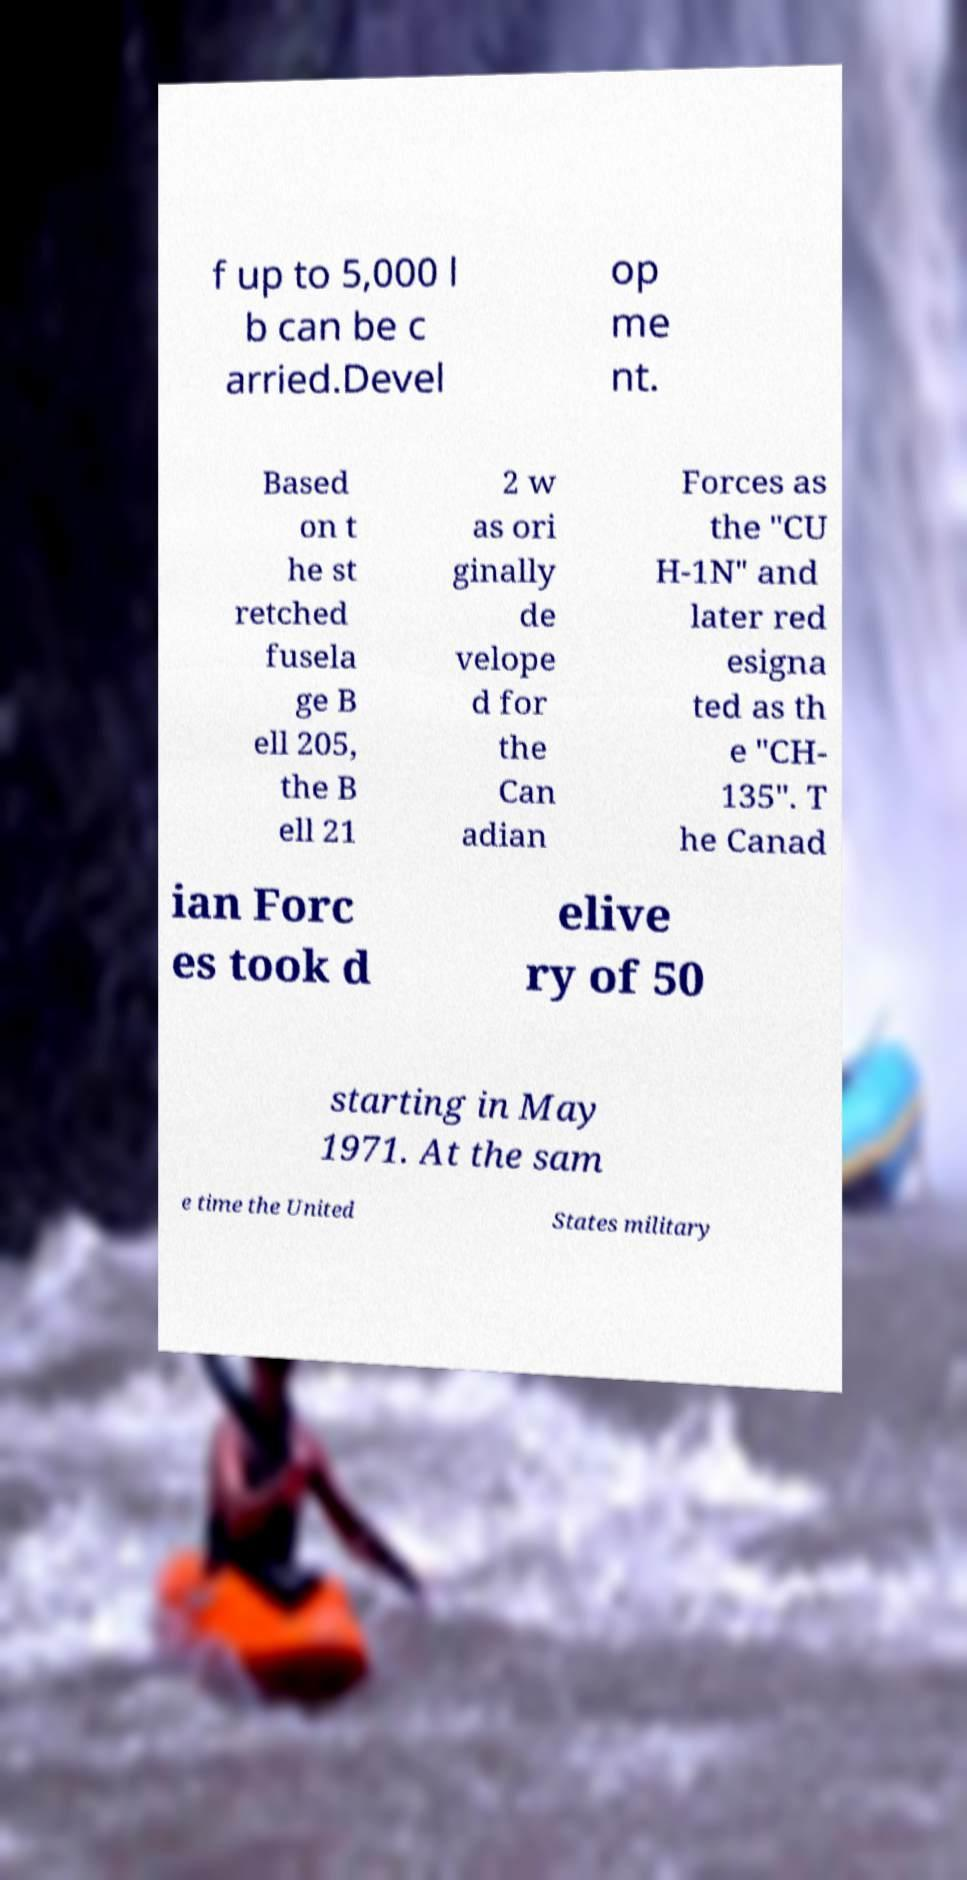What messages or text are displayed in this image? I need them in a readable, typed format. f up to 5,000 l b can be c arried.Devel op me nt. Based on t he st retched fusela ge B ell 205, the B ell 21 2 w as ori ginally de velope d for the Can adian Forces as the "CU H-1N" and later red esigna ted as th e "CH- 135". T he Canad ian Forc es took d elive ry of 50 starting in May 1971. At the sam e time the United States military 